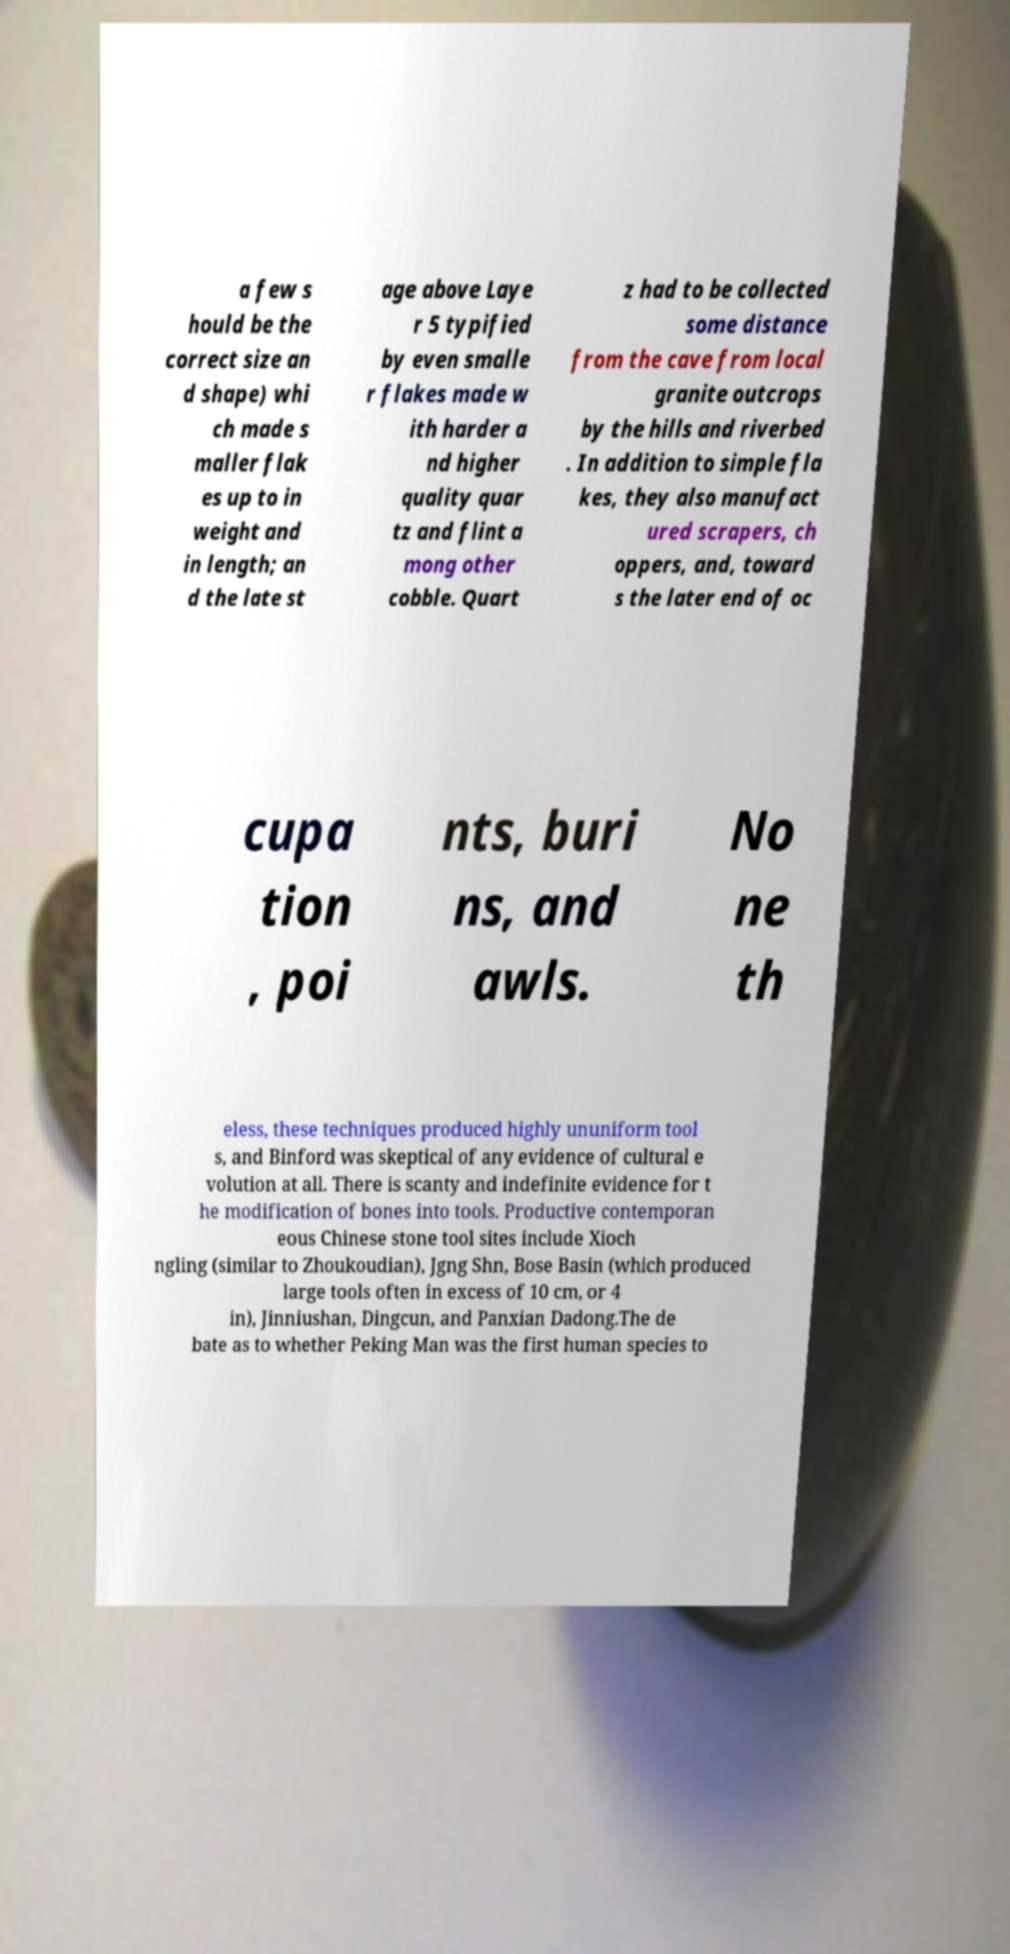Please identify and transcribe the text found in this image. a few s hould be the correct size an d shape) whi ch made s maller flak es up to in weight and in length; an d the late st age above Laye r 5 typified by even smalle r flakes made w ith harder a nd higher quality quar tz and flint a mong other cobble. Quart z had to be collected some distance from the cave from local granite outcrops by the hills and riverbed . In addition to simple fla kes, they also manufact ured scrapers, ch oppers, and, toward s the later end of oc cupa tion , poi nts, buri ns, and awls. No ne th eless, these techniques produced highly ununiform tool s, and Binford was skeptical of any evidence of cultural e volution at all. There is scanty and indefinite evidence for t he modification of bones into tools. Productive contemporan eous Chinese stone tool sites include Xioch ngling (similar to Zhoukoudian), Jgng Shn, Bose Basin (which produced large tools often in excess of 10 cm, or 4 in), Jinniushan, Dingcun, and Panxian Dadong.The de bate as to whether Peking Man was the first human species to 